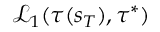Convert formula to latex. <formula><loc_0><loc_0><loc_500><loc_500>\mathcal { L } _ { 1 } ( \tau ( s _ { T } ) , \tau ^ { * } )</formula> 